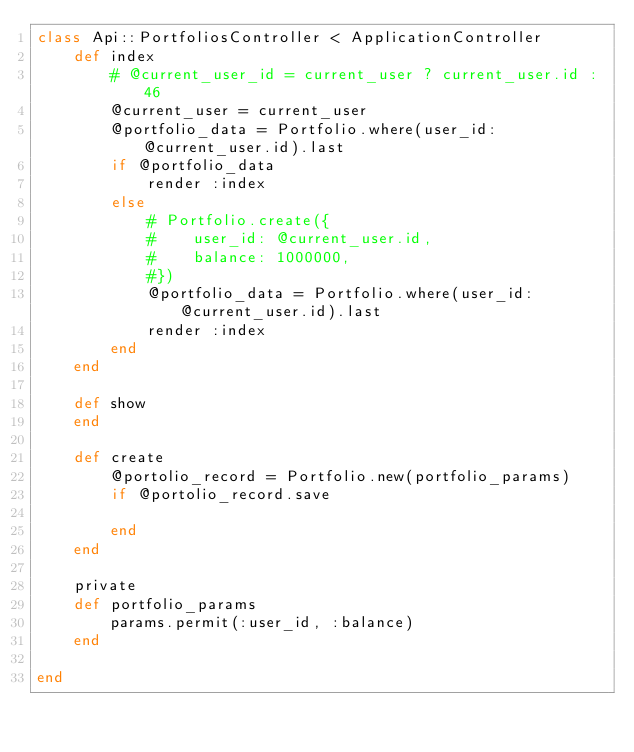Convert code to text. <code><loc_0><loc_0><loc_500><loc_500><_Ruby_>class Api::PortfoliosController < ApplicationController
    def index
        # @current_user_id = current_user ? current_user.id : 46
        @current_user = current_user
        @portfolio_data = Portfolio.where(user_id: @current_user.id).last
        if @portfolio_data
            render :index
        else
            # Portfolio.create({
            #    user_id: @current_user.id,
            #    balance: 1000000,
            #})
            @portfolio_data = Portfolio.where(user_id: @current_user.id).last
            render :index
        end
    end

    def show
    end
    
    def create
        @portolio_record = Portfolio.new(portfolio_params)
        if @portolio_record.save
            
        end
    end

    private
    def portfolio_params
        params.permit(:user_id, :balance)
    end

end
</code> 